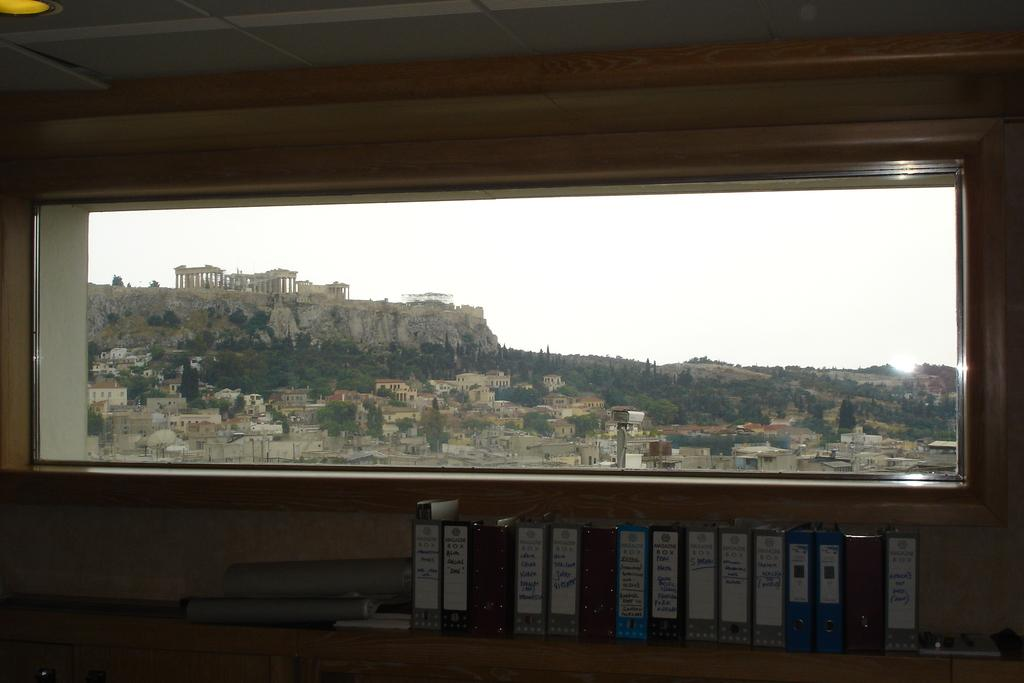What objects are located at the bottom of the image? There are files at the bottom of the image. What is in the middle of the image? There is a glass in the middle of the image. What can be seen through the glass in the image? Buildings, trees, and the sky are visible through the glass. What type of rhythm can be heard coming from the shop in the image? There is no shop present in the image, so it's not possible to determine what rhythm might be heard. 